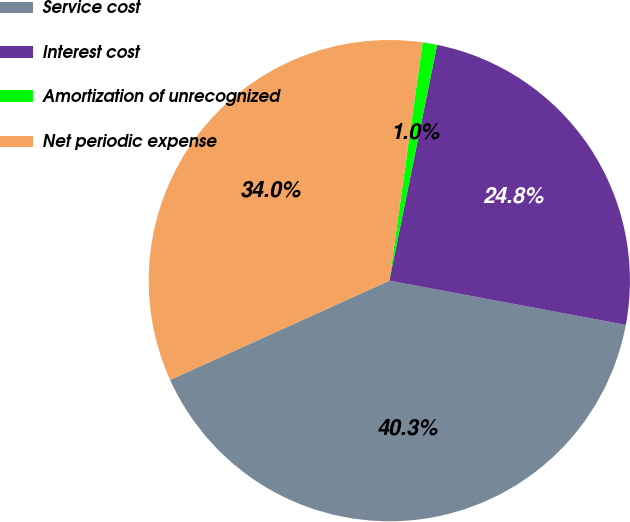Convert chart to OTSL. <chart><loc_0><loc_0><loc_500><loc_500><pie_chart><fcel>Service cost<fcel>Interest cost<fcel>Amortization of unrecognized<fcel>Net periodic expense<nl><fcel>40.29%<fcel>24.76%<fcel>0.97%<fcel>33.98%<nl></chart> 